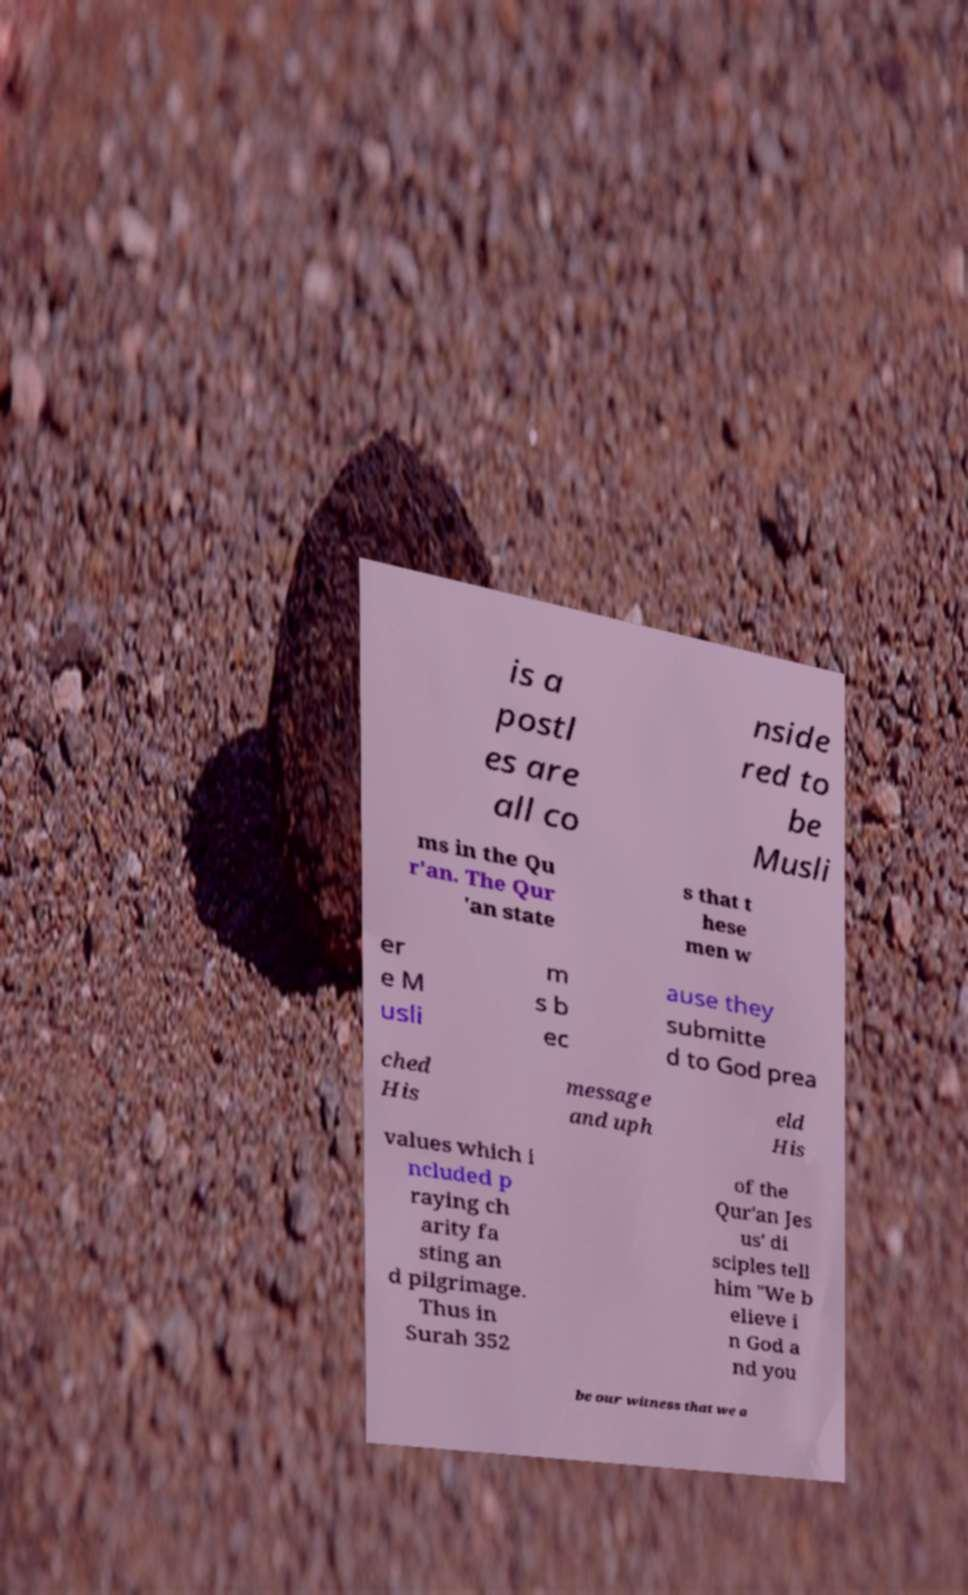Could you assist in decoding the text presented in this image and type it out clearly? is a postl es are all co nside red to be Musli ms in the Qu r'an. The Qur 'an state s that t hese men w er e M usli m s b ec ause they submitte d to God prea ched His message and uph eld His values which i ncluded p raying ch arity fa sting an d pilgrimage. Thus in Surah 352 of the Qur'an Jes us' di sciples tell him "We b elieve i n God a nd you be our witness that we a 